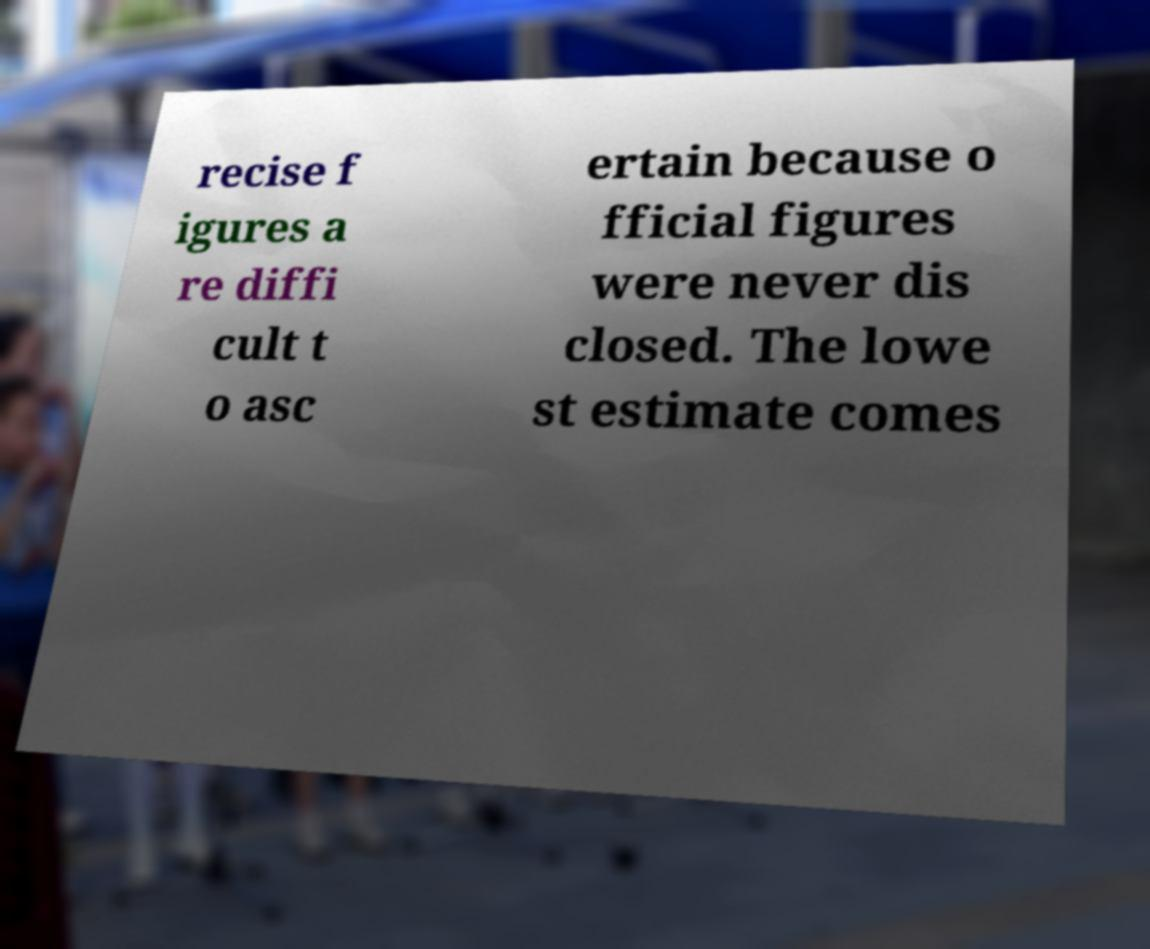There's text embedded in this image that I need extracted. Can you transcribe it verbatim? recise f igures a re diffi cult t o asc ertain because o fficial figures were never dis closed. The lowe st estimate comes 